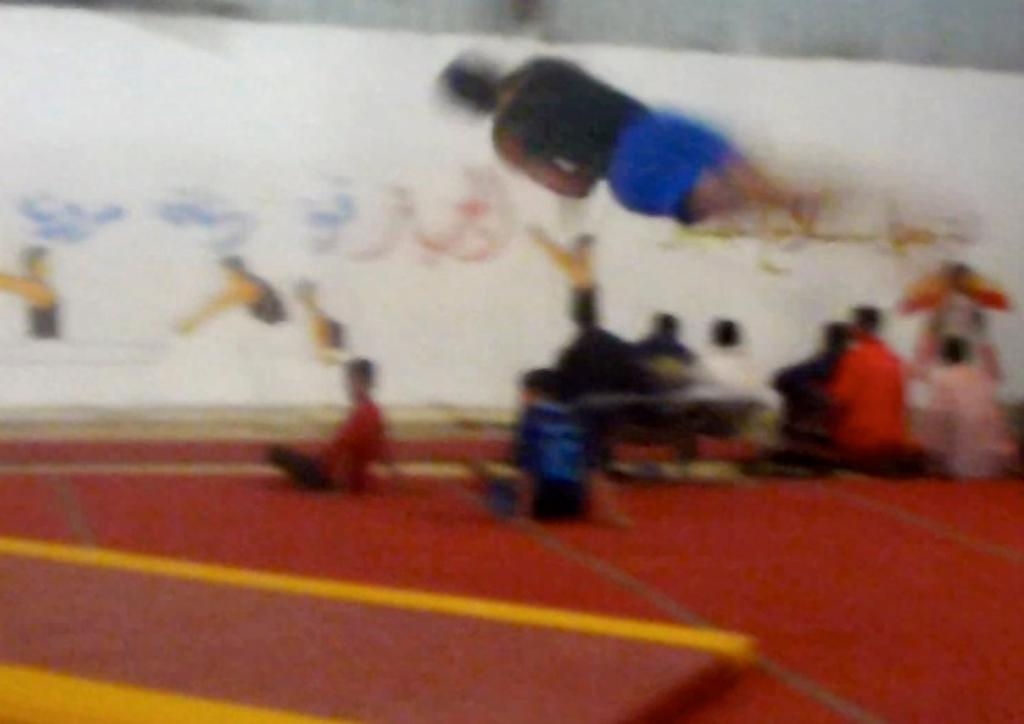What are the people in the image doing? The people in the image are sitting on the ground. Is there anyone in the image who is not sitting on the ground? Yes, there is a person in the air in the image. What else can be seen in the image besides the people? There are objects in the image. How would you describe the quality of the image? The image is blurry. What type of scarf is the kitten wearing in the image? There are no kittens or scarves present in the image. 